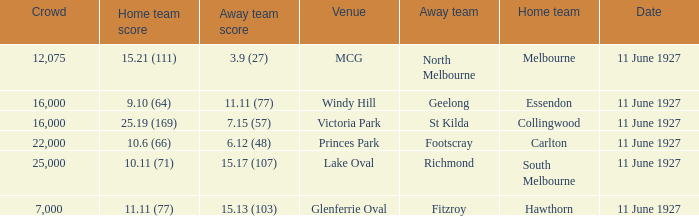What is the sum of all crowds present at the Glenferrie Oval venue? 7000.0. 